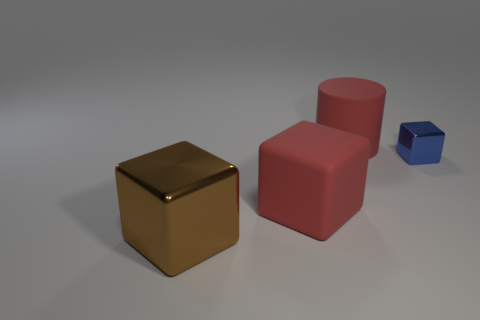Subtract all big cubes. How many cubes are left? 1 Subtract all red cubes. How many cubes are left? 2 Subtract all blocks. How many objects are left? 1 Add 2 tiny gray metallic cylinders. How many objects exist? 6 Add 4 big brown objects. How many big brown objects exist? 5 Subtract 1 red cylinders. How many objects are left? 3 Subtract all yellow cubes. Subtract all brown cylinders. How many cubes are left? 3 Subtract all yellow cubes. How many blue cylinders are left? 0 Subtract all yellow metal cubes. Subtract all metallic things. How many objects are left? 2 Add 2 big red rubber cylinders. How many big red rubber cylinders are left? 3 